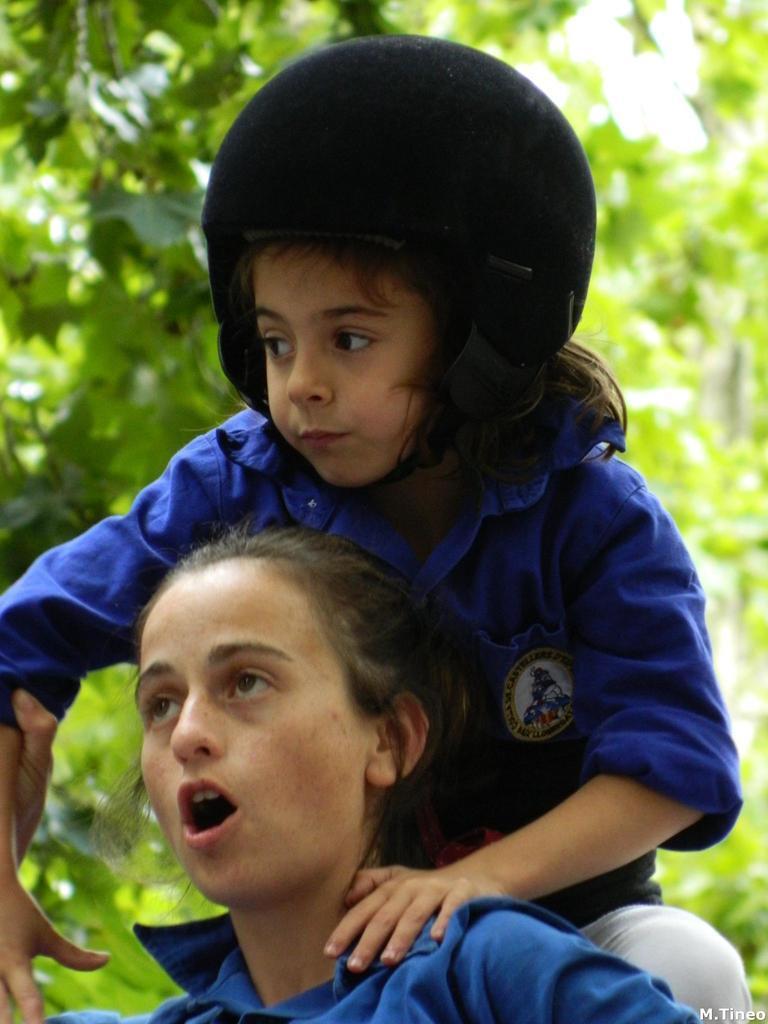Could you give a brief overview of what you see in this image? In this image we can see people wearing blue dresses. In the background there are trees. 